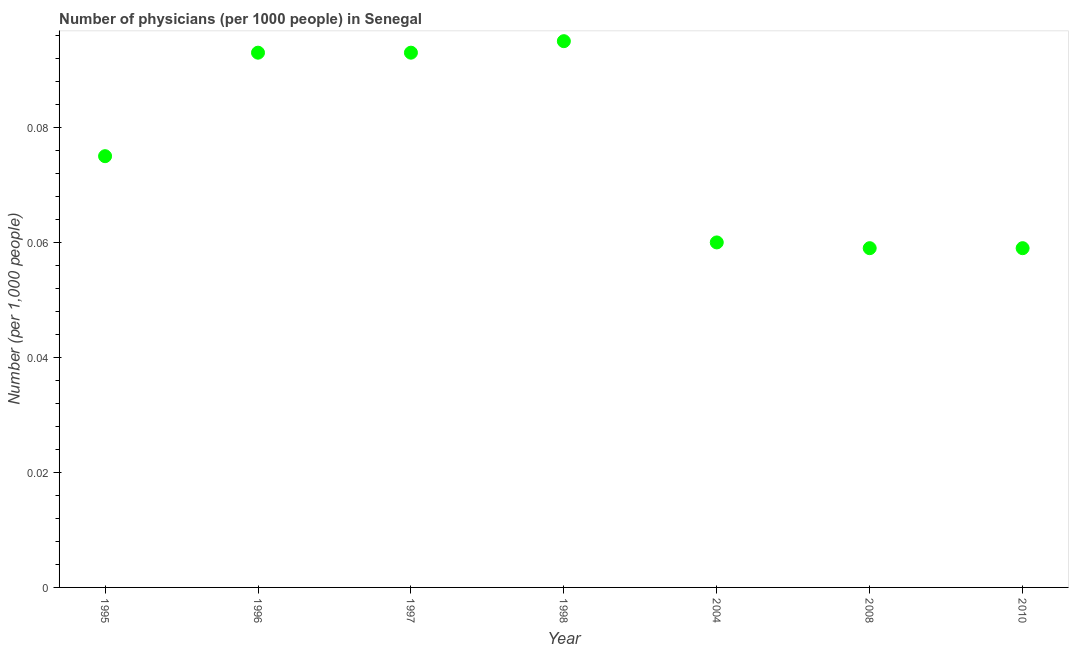What is the number of physicians in 1996?
Keep it short and to the point. 0.09. Across all years, what is the maximum number of physicians?
Your response must be concise. 0.1. Across all years, what is the minimum number of physicians?
Offer a very short reply. 0.06. In which year was the number of physicians maximum?
Give a very brief answer. 1998. In which year was the number of physicians minimum?
Give a very brief answer. 2008. What is the sum of the number of physicians?
Your response must be concise. 0.53. What is the difference between the number of physicians in 1996 and 2004?
Provide a short and direct response. 0.03. What is the average number of physicians per year?
Offer a terse response. 0.08. What is the median number of physicians?
Your response must be concise. 0.07. In how many years, is the number of physicians greater than 0.04 ?
Ensure brevity in your answer.  7. Do a majority of the years between 2004 and 2008 (inclusive) have number of physicians greater than 0.008 ?
Your response must be concise. Yes. What is the ratio of the number of physicians in 1996 to that in 2008?
Give a very brief answer. 1.58. What is the difference between the highest and the second highest number of physicians?
Give a very brief answer. 0. Is the sum of the number of physicians in 1998 and 2008 greater than the maximum number of physicians across all years?
Offer a very short reply. Yes. What is the difference between the highest and the lowest number of physicians?
Ensure brevity in your answer.  0.04. Does the number of physicians monotonically increase over the years?
Ensure brevity in your answer.  No. How many dotlines are there?
Offer a terse response. 1. What is the difference between two consecutive major ticks on the Y-axis?
Give a very brief answer. 0.02. Does the graph contain any zero values?
Provide a succinct answer. No. Does the graph contain grids?
Ensure brevity in your answer.  No. What is the title of the graph?
Offer a terse response. Number of physicians (per 1000 people) in Senegal. What is the label or title of the Y-axis?
Offer a terse response. Number (per 1,0 people). What is the Number (per 1,000 people) in 1995?
Ensure brevity in your answer.  0.07. What is the Number (per 1,000 people) in 1996?
Offer a terse response. 0.09. What is the Number (per 1,000 people) in 1997?
Your response must be concise. 0.09. What is the Number (per 1,000 people) in 1998?
Ensure brevity in your answer.  0.1. What is the Number (per 1,000 people) in 2004?
Your answer should be very brief. 0.06. What is the Number (per 1,000 people) in 2008?
Your answer should be compact. 0.06. What is the Number (per 1,000 people) in 2010?
Make the answer very short. 0.06. What is the difference between the Number (per 1,000 people) in 1995 and 1996?
Give a very brief answer. -0.02. What is the difference between the Number (per 1,000 people) in 1995 and 1997?
Keep it short and to the point. -0.02. What is the difference between the Number (per 1,000 people) in 1995 and 1998?
Ensure brevity in your answer.  -0.02. What is the difference between the Number (per 1,000 people) in 1995 and 2004?
Offer a terse response. 0.01. What is the difference between the Number (per 1,000 people) in 1995 and 2008?
Your response must be concise. 0.02. What is the difference between the Number (per 1,000 people) in 1995 and 2010?
Keep it short and to the point. 0.02. What is the difference between the Number (per 1,000 people) in 1996 and 1997?
Your response must be concise. 0. What is the difference between the Number (per 1,000 people) in 1996 and 1998?
Provide a succinct answer. -0. What is the difference between the Number (per 1,000 people) in 1996 and 2004?
Your response must be concise. 0.03. What is the difference between the Number (per 1,000 people) in 1996 and 2008?
Offer a terse response. 0.03. What is the difference between the Number (per 1,000 people) in 1996 and 2010?
Keep it short and to the point. 0.03. What is the difference between the Number (per 1,000 people) in 1997 and 1998?
Make the answer very short. -0. What is the difference between the Number (per 1,000 people) in 1997 and 2004?
Offer a very short reply. 0.03. What is the difference between the Number (per 1,000 people) in 1997 and 2008?
Keep it short and to the point. 0.03. What is the difference between the Number (per 1,000 people) in 1997 and 2010?
Your response must be concise. 0.03. What is the difference between the Number (per 1,000 people) in 1998 and 2004?
Your response must be concise. 0.04. What is the difference between the Number (per 1,000 people) in 1998 and 2008?
Offer a very short reply. 0.04. What is the difference between the Number (per 1,000 people) in 1998 and 2010?
Your answer should be compact. 0.04. What is the difference between the Number (per 1,000 people) in 2004 and 2008?
Make the answer very short. 0. What is the difference between the Number (per 1,000 people) in 2004 and 2010?
Your answer should be compact. 0. What is the difference between the Number (per 1,000 people) in 2008 and 2010?
Keep it short and to the point. 0. What is the ratio of the Number (per 1,000 people) in 1995 to that in 1996?
Offer a very short reply. 0.81. What is the ratio of the Number (per 1,000 people) in 1995 to that in 1997?
Your answer should be compact. 0.81. What is the ratio of the Number (per 1,000 people) in 1995 to that in 1998?
Your answer should be very brief. 0.79. What is the ratio of the Number (per 1,000 people) in 1995 to that in 2004?
Ensure brevity in your answer.  1.25. What is the ratio of the Number (per 1,000 people) in 1995 to that in 2008?
Ensure brevity in your answer.  1.27. What is the ratio of the Number (per 1,000 people) in 1995 to that in 2010?
Your answer should be compact. 1.27. What is the ratio of the Number (per 1,000 people) in 1996 to that in 2004?
Offer a terse response. 1.55. What is the ratio of the Number (per 1,000 people) in 1996 to that in 2008?
Offer a very short reply. 1.58. What is the ratio of the Number (per 1,000 people) in 1996 to that in 2010?
Keep it short and to the point. 1.58. What is the ratio of the Number (per 1,000 people) in 1997 to that in 1998?
Provide a short and direct response. 0.98. What is the ratio of the Number (per 1,000 people) in 1997 to that in 2004?
Give a very brief answer. 1.55. What is the ratio of the Number (per 1,000 people) in 1997 to that in 2008?
Ensure brevity in your answer.  1.58. What is the ratio of the Number (per 1,000 people) in 1997 to that in 2010?
Make the answer very short. 1.58. What is the ratio of the Number (per 1,000 people) in 1998 to that in 2004?
Ensure brevity in your answer.  1.58. What is the ratio of the Number (per 1,000 people) in 1998 to that in 2008?
Keep it short and to the point. 1.61. What is the ratio of the Number (per 1,000 people) in 1998 to that in 2010?
Offer a very short reply. 1.61. What is the ratio of the Number (per 1,000 people) in 2004 to that in 2010?
Give a very brief answer. 1.02. 